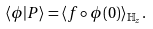Convert formula to latex. <formula><loc_0><loc_0><loc_500><loc_500>\langle \phi | P \rangle = \langle f \circ \phi ( 0 ) \rangle _ { \mathbb { H } _ { z } } .</formula> 